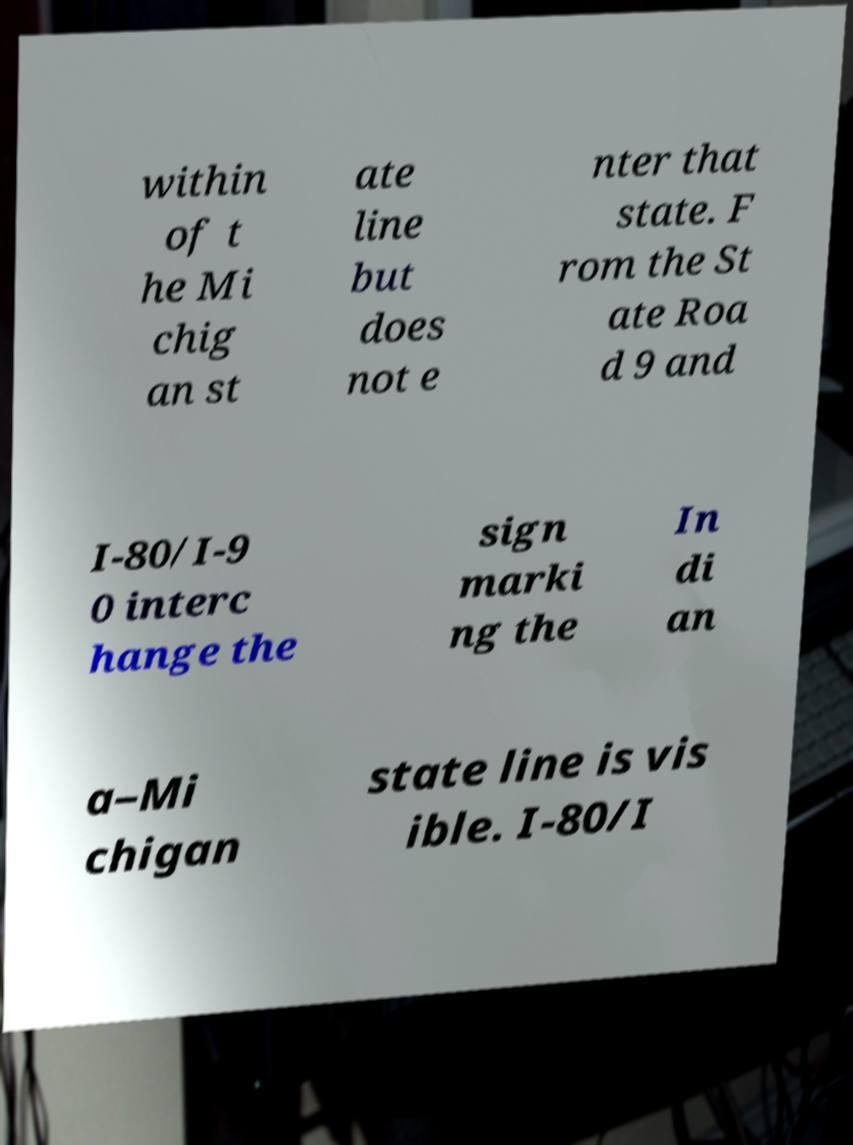I need the written content from this picture converted into text. Can you do that? within of t he Mi chig an st ate line but does not e nter that state. F rom the St ate Roa d 9 and I-80/I-9 0 interc hange the sign marki ng the In di an a–Mi chigan state line is vis ible. I-80/I 